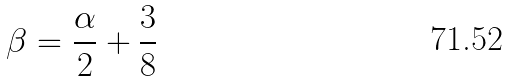<formula> <loc_0><loc_0><loc_500><loc_500>\beta = \frac { \alpha } { 2 } + \frac { 3 } { 8 }</formula> 